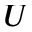Convert formula to latex. <formula><loc_0><loc_0><loc_500><loc_500>U</formula> 